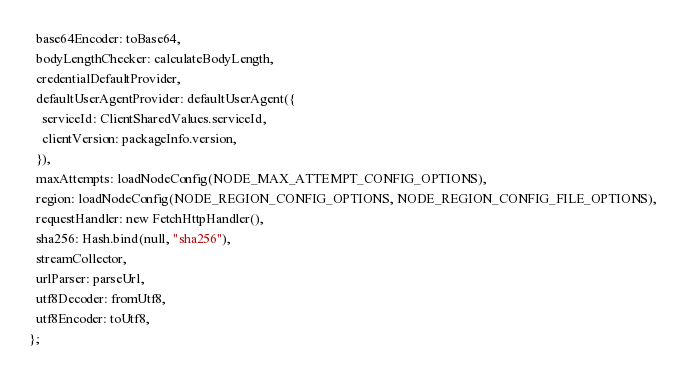<code> <loc_0><loc_0><loc_500><loc_500><_TypeScript_>  base64Encoder: toBase64,
  bodyLengthChecker: calculateBodyLength,
  credentialDefaultProvider,
  defaultUserAgentProvider: defaultUserAgent({
    serviceId: ClientSharedValues.serviceId,
    clientVersion: packageInfo.version,
  }),
  maxAttempts: loadNodeConfig(NODE_MAX_ATTEMPT_CONFIG_OPTIONS),
  region: loadNodeConfig(NODE_REGION_CONFIG_OPTIONS, NODE_REGION_CONFIG_FILE_OPTIONS),
  requestHandler: new FetchHttpHandler(),
  sha256: Hash.bind(null, "sha256"),
  streamCollector,
  urlParser: parseUrl,
  utf8Decoder: fromUtf8,
  utf8Encoder: toUtf8,
};
</code> 